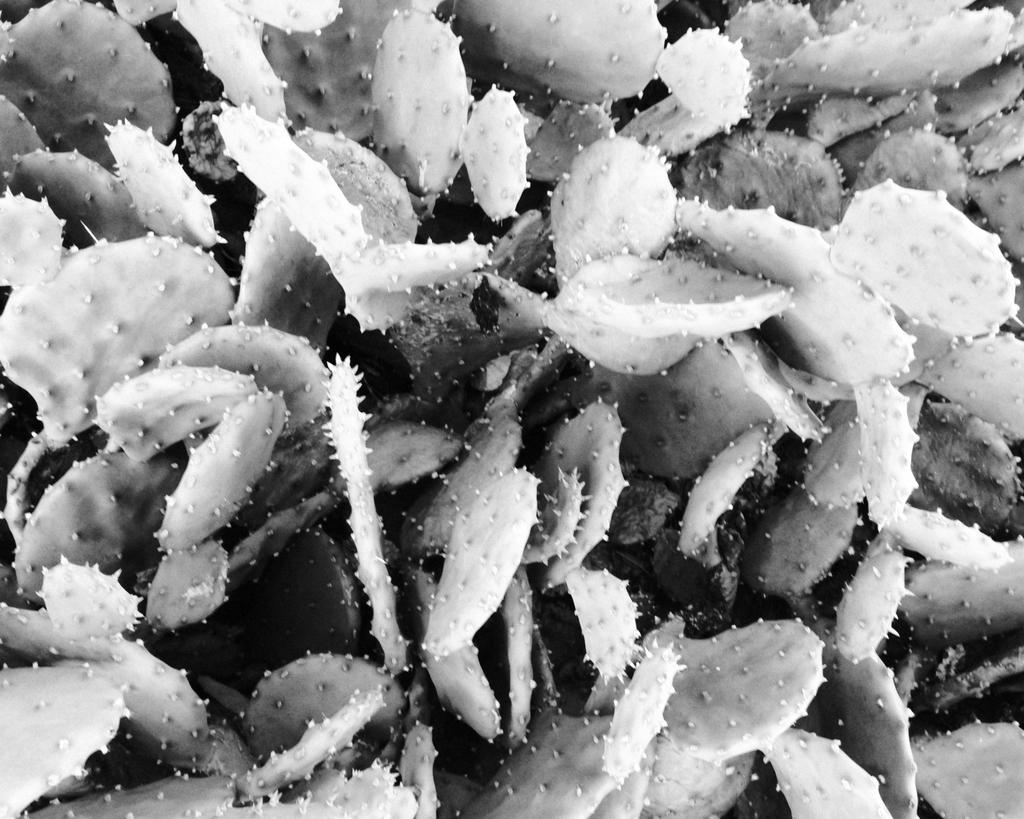What type of plants are in the image? There are cactus plants in the image. Can you describe the appearance of the cactus plants? The cactus plants have spiky features and may have different shapes and sizes. Are there any other objects or elements in the image besides the cactus plants? The provided facts do not mention any other objects or elements in the image. What type of hook can be seen hanging from the kite in the image? There is no kite or hook present in the image; it only features cactus plants. 